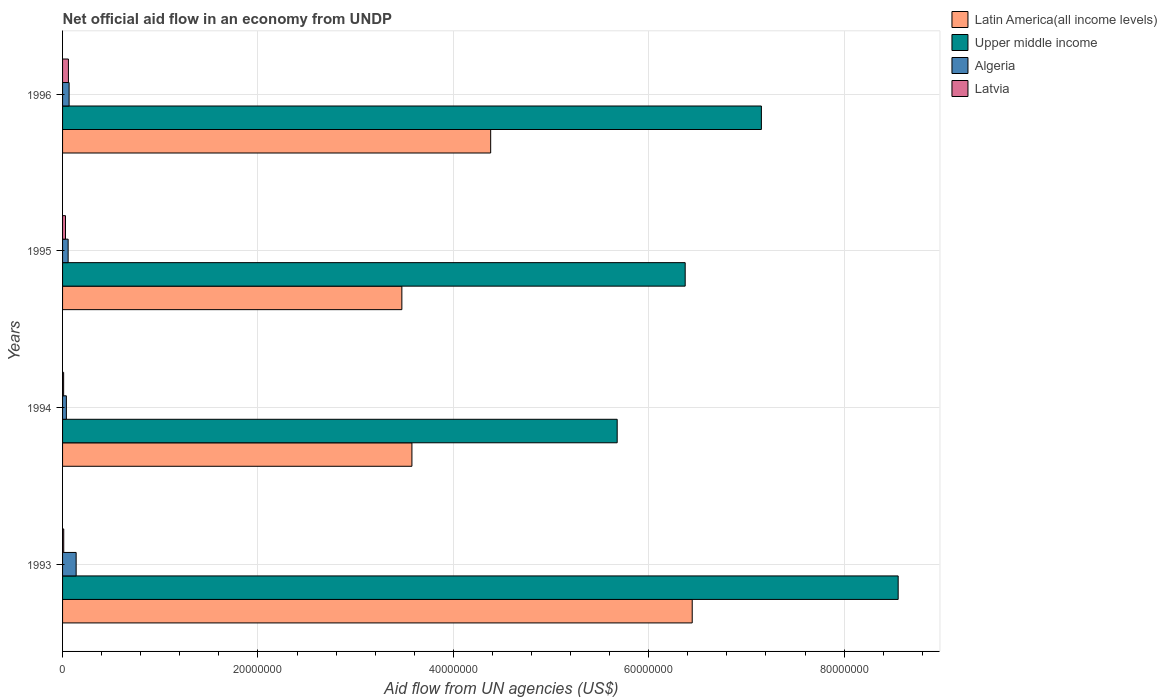Are the number of bars per tick equal to the number of legend labels?
Give a very brief answer. Yes. How many bars are there on the 2nd tick from the top?
Give a very brief answer. 4. In how many cases, is the number of bars for a given year not equal to the number of legend labels?
Make the answer very short. 0. What is the net official aid flow in Algeria in 1994?
Ensure brevity in your answer.  3.90e+05. Across all years, what is the maximum net official aid flow in Upper middle income?
Give a very brief answer. 8.55e+07. What is the total net official aid flow in Latvia in the graph?
Provide a succinct answer. 1.13e+06. What is the difference between the net official aid flow in Upper middle income in 1994 and that in 1996?
Give a very brief answer. -1.48e+07. What is the difference between the net official aid flow in Algeria in 1994 and the net official aid flow in Upper middle income in 1995?
Keep it short and to the point. -6.33e+07. What is the average net official aid flow in Latin America(all income levels) per year?
Give a very brief answer. 4.47e+07. In the year 1995, what is the difference between the net official aid flow in Algeria and net official aid flow in Latvia?
Ensure brevity in your answer.  2.70e+05. In how many years, is the net official aid flow in Algeria greater than 52000000 US$?
Provide a short and direct response. 0. What is the ratio of the net official aid flow in Upper middle income in 1993 to that in 1995?
Your answer should be very brief. 1.34. Is the net official aid flow in Latin America(all income levels) in 1993 less than that in 1996?
Your answer should be very brief. No. Is the difference between the net official aid flow in Algeria in 1993 and 1994 greater than the difference between the net official aid flow in Latvia in 1993 and 1994?
Ensure brevity in your answer.  Yes. What is the difference between the highest and the lowest net official aid flow in Latvia?
Keep it short and to the point. 4.90e+05. Is it the case that in every year, the sum of the net official aid flow in Algeria and net official aid flow in Upper middle income is greater than the sum of net official aid flow in Latin America(all income levels) and net official aid flow in Latvia?
Give a very brief answer. Yes. What does the 4th bar from the top in 1993 represents?
Offer a terse response. Latin America(all income levels). What does the 2nd bar from the bottom in 1996 represents?
Offer a terse response. Upper middle income. How many bars are there?
Ensure brevity in your answer.  16. How many years are there in the graph?
Your response must be concise. 4. What is the difference between two consecutive major ticks on the X-axis?
Keep it short and to the point. 2.00e+07. Are the values on the major ticks of X-axis written in scientific E-notation?
Offer a very short reply. No. Does the graph contain any zero values?
Offer a very short reply. No. Does the graph contain grids?
Offer a very short reply. Yes. What is the title of the graph?
Give a very brief answer. Net official aid flow in an economy from UNDP. What is the label or title of the X-axis?
Your answer should be very brief. Aid flow from UN agencies (US$). What is the Aid flow from UN agencies (US$) in Latin America(all income levels) in 1993?
Make the answer very short. 6.44e+07. What is the Aid flow from UN agencies (US$) of Upper middle income in 1993?
Give a very brief answer. 8.55e+07. What is the Aid flow from UN agencies (US$) in Algeria in 1993?
Provide a succinct answer. 1.39e+06. What is the Aid flow from UN agencies (US$) in Latvia in 1993?
Ensure brevity in your answer.  1.20e+05. What is the Aid flow from UN agencies (US$) in Latin America(all income levels) in 1994?
Your answer should be compact. 3.58e+07. What is the Aid flow from UN agencies (US$) in Upper middle income in 1994?
Offer a terse response. 5.68e+07. What is the Aid flow from UN agencies (US$) in Algeria in 1994?
Ensure brevity in your answer.  3.90e+05. What is the Aid flow from UN agencies (US$) in Latvia in 1994?
Provide a short and direct response. 1.10e+05. What is the Aid flow from UN agencies (US$) in Latin America(all income levels) in 1995?
Ensure brevity in your answer.  3.47e+07. What is the Aid flow from UN agencies (US$) of Upper middle income in 1995?
Your answer should be compact. 6.37e+07. What is the Aid flow from UN agencies (US$) in Algeria in 1995?
Provide a succinct answer. 5.70e+05. What is the Aid flow from UN agencies (US$) in Latin America(all income levels) in 1996?
Your answer should be very brief. 4.38e+07. What is the Aid flow from UN agencies (US$) in Upper middle income in 1996?
Make the answer very short. 7.15e+07. What is the Aid flow from UN agencies (US$) of Algeria in 1996?
Your answer should be compact. 6.70e+05. What is the Aid flow from UN agencies (US$) in Latvia in 1996?
Offer a very short reply. 6.00e+05. Across all years, what is the maximum Aid flow from UN agencies (US$) of Latin America(all income levels)?
Keep it short and to the point. 6.44e+07. Across all years, what is the maximum Aid flow from UN agencies (US$) in Upper middle income?
Provide a short and direct response. 8.55e+07. Across all years, what is the maximum Aid flow from UN agencies (US$) in Algeria?
Your answer should be compact. 1.39e+06. Across all years, what is the minimum Aid flow from UN agencies (US$) of Latin America(all income levels)?
Ensure brevity in your answer.  3.47e+07. Across all years, what is the minimum Aid flow from UN agencies (US$) in Upper middle income?
Your response must be concise. 5.68e+07. What is the total Aid flow from UN agencies (US$) of Latin America(all income levels) in the graph?
Offer a terse response. 1.79e+08. What is the total Aid flow from UN agencies (US$) in Upper middle income in the graph?
Offer a very short reply. 2.78e+08. What is the total Aid flow from UN agencies (US$) of Algeria in the graph?
Your answer should be compact. 3.02e+06. What is the total Aid flow from UN agencies (US$) of Latvia in the graph?
Provide a short and direct response. 1.13e+06. What is the difference between the Aid flow from UN agencies (US$) of Latin America(all income levels) in 1993 and that in 1994?
Give a very brief answer. 2.87e+07. What is the difference between the Aid flow from UN agencies (US$) of Upper middle income in 1993 and that in 1994?
Ensure brevity in your answer.  2.88e+07. What is the difference between the Aid flow from UN agencies (US$) in Algeria in 1993 and that in 1994?
Ensure brevity in your answer.  1.00e+06. What is the difference between the Aid flow from UN agencies (US$) of Latvia in 1993 and that in 1994?
Offer a very short reply. 10000. What is the difference between the Aid flow from UN agencies (US$) of Latin America(all income levels) in 1993 and that in 1995?
Your response must be concise. 2.97e+07. What is the difference between the Aid flow from UN agencies (US$) of Upper middle income in 1993 and that in 1995?
Your response must be concise. 2.18e+07. What is the difference between the Aid flow from UN agencies (US$) of Algeria in 1993 and that in 1995?
Keep it short and to the point. 8.20e+05. What is the difference between the Aid flow from UN agencies (US$) in Latin America(all income levels) in 1993 and that in 1996?
Your response must be concise. 2.06e+07. What is the difference between the Aid flow from UN agencies (US$) of Upper middle income in 1993 and that in 1996?
Make the answer very short. 1.40e+07. What is the difference between the Aid flow from UN agencies (US$) of Algeria in 1993 and that in 1996?
Provide a succinct answer. 7.20e+05. What is the difference between the Aid flow from UN agencies (US$) in Latvia in 1993 and that in 1996?
Your answer should be compact. -4.80e+05. What is the difference between the Aid flow from UN agencies (US$) in Latin America(all income levels) in 1994 and that in 1995?
Provide a succinct answer. 1.03e+06. What is the difference between the Aid flow from UN agencies (US$) of Upper middle income in 1994 and that in 1995?
Give a very brief answer. -6.96e+06. What is the difference between the Aid flow from UN agencies (US$) of Algeria in 1994 and that in 1995?
Make the answer very short. -1.80e+05. What is the difference between the Aid flow from UN agencies (US$) of Latin America(all income levels) in 1994 and that in 1996?
Your response must be concise. -8.06e+06. What is the difference between the Aid flow from UN agencies (US$) of Upper middle income in 1994 and that in 1996?
Make the answer very short. -1.48e+07. What is the difference between the Aid flow from UN agencies (US$) in Algeria in 1994 and that in 1996?
Provide a succinct answer. -2.80e+05. What is the difference between the Aid flow from UN agencies (US$) in Latvia in 1994 and that in 1996?
Offer a very short reply. -4.90e+05. What is the difference between the Aid flow from UN agencies (US$) in Latin America(all income levels) in 1995 and that in 1996?
Give a very brief answer. -9.09e+06. What is the difference between the Aid flow from UN agencies (US$) of Upper middle income in 1995 and that in 1996?
Provide a short and direct response. -7.80e+06. What is the difference between the Aid flow from UN agencies (US$) of Algeria in 1995 and that in 1996?
Your response must be concise. -1.00e+05. What is the difference between the Aid flow from UN agencies (US$) in Latin America(all income levels) in 1993 and the Aid flow from UN agencies (US$) in Upper middle income in 1994?
Your response must be concise. 7.68e+06. What is the difference between the Aid flow from UN agencies (US$) of Latin America(all income levels) in 1993 and the Aid flow from UN agencies (US$) of Algeria in 1994?
Provide a short and direct response. 6.41e+07. What is the difference between the Aid flow from UN agencies (US$) in Latin America(all income levels) in 1993 and the Aid flow from UN agencies (US$) in Latvia in 1994?
Ensure brevity in your answer.  6.43e+07. What is the difference between the Aid flow from UN agencies (US$) in Upper middle income in 1993 and the Aid flow from UN agencies (US$) in Algeria in 1994?
Your response must be concise. 8.51e+07. What is the difference between the Aid flow from UN agencies (US$) of Upper middle income in 1993 and the Aid flow from UN agencies (US$) of Latvia in 1994?
Ensure brevity in your answer.  8.54e+07. What is the difference between the Aid flow from UN agencies (US$) in Algeria in 1993 and the Aid flow from UN agencies (US$) in Latvia in 1994?
Your response must be concise. 1.28e+06. What is the difference between the Aid flow from UN agencies (US$) of Latin America(all income levels) in 1993 and the Aid flow from UN agencies (US$) of Upper middle income in 1995?
Provide a succinct answer. 7.20e+05. What is the difference between the Aid flow from UN agencies (US$) in Latin America(all income levels) in 1993 and the Aid flow from UN agencies (US$) in Algeria in 1995?
Keep it short and to the point. 6.39e+07. What is the difference between the Aid flow from UN agencies (US$) in Latin America(all income levels) in 1993 and the Aid flow from UN agencies (US$) in Latvia in 1995?
Your response must be concise. 6.42e+07. What is the difference between the Aid flow from UN agencies (US$) of Upper middle income in 1993 and the Aid flow from UN agencies (US$) of Algeria in 1995?
Make the answer very short. 8.50e+07. What is the difference between the Aid flow from UN agencies (US$) in Upper middle income in 1993 and the Aid flow from UN agencies (US$) in Latvia in 1995?
Offer a very short reply. 8.52e+07. What is the difference between the Aid flow from UN agencies (US$) in Algeria in 1993 and the Aid flow from UN agencies (US$) in Latvia in 1995?
Give a very brief answer. 1.09e+06. What is the difference between the Aid flow from UN agencies (US$) in Latin America(all income levels) in 1993 and the Aid flow from UN agencies (US$) in Upper middle income in 1996?
Provide a short and direct response. -7.08e+06. What is the difference between the Aid flow from UN agencies (US$) of Latin America(all income levels) in 1993 and the Aid flow from UN agencies (US$) of Algeria in 1996?
Keep it short and to the point. 6.38e+07. What is the difference between the Aid flow from UN agencies (US$) of Latin America(all income levels) in 1993 and the Aid flow from UN agencies (US$) of Latvia in 1996?
Provide a succinct answer. 6.38e+07. What is the difference between the Aid flow from UN agencies (US$) of Upper middle income in 1993 and the Aid flow from UN agencies (US$) of Algeria in 1996?
Offer a terse response. 8.49e+07. What is the difference between the Aid flow from UN agencies (US$) in Upper middle income in 1993 and the Aid flow from UN agencies (US$) in Latvia in 1996?
Make the answer very short. 8.49e+07. What is the difference between the Aid flow from UN agencies (US$) in Algeria in 1993 and the Aid flow from UN agencies (US$) in Latvia in 1996?
Your answer should be compact. 7.90e+05. What is the difference between the Aid flow from UN agencies (US$) in Latin America(all income levels) in 1994 and the Aid flow from UN agencies (US$) in Upper middle income in 1995?
Keep it short and to the point. -2.80e+07. What is the difference between the Aid flow from UN agencies (US$) of Latin America(all income levels) in 1994 and the Aid flow from UN agencies (US$) of Algeria in 1995?
Offer a terse response. 3.52e+07. What is the difference between the Aid flow from UN agencies (US$) of Latin America(all income levels) in 1994 and the Aid flow from UN agencies (US$) of Latvia in 1995?
Your response must be concise. 3.55e+07. What is the difference between the Aid flow from UN agencies (US$) of Upper middle income in 1994 and the Aid flow from UN agencies (US$) of Algeria in 1995?
Make the answer very short. 5.62e+07. What is the difference between the Aid flow from UN agencies (US$) in Upper middle income in 1994 and the Aid flow from UN agencies (US$) in Latvia in 1995?
Give a very brief answer. 5.65e+07. What is the difference between the Aid flow from UN agencies (US$) of Latin America(all income levels) in 1994 and the Aid flow from UN agencies (US$) of Upper middle income in 1996?
Provide a short and direct response. -3.58e+07. What is the difference between the Aid flow from UN agencies (US$) in Latin America(all income levels) in 1994 and the Aid flow from UN agencies (US$) in Algeria in 1996?
Your answer should be compact. 3.51e+07. What is the difference between the Aid flow from UN agencies (US$) in Latin America(all income levels) in 1994 and the Aid flow from UN agencies (US$) in Latvia in 1996?
Your answer should be very brief. 3.52e+07. What is the difference between the Aid flow from UN agencies (US$) in Upper middle income in 1994 and the Aid flow from UN agencies (US$) in Algeria in 1996?
Offer a very short reply. 5.61e+07. What is the difference between the Aid flow from UN agencies (US$) of Upper middle income in 1994 and the Aid flow from UN agencies (US$) of Latvia in 1996?
Offer a very short reply. 5.62e+07. What is the difference between the Aid flow from UN agencies (US$) in Algeria in 1994 and the Aid flow from UN agencies (US$) in Latvia in 1996?
Ensure brevity in your answer.  -2.10e+05. What is the difference between the Aid flow from UN agencies (US$) of Latin America(all income levels) in 1995 and the Aid flow from UN agencies (US$) of Upper middle income in 1996?
Keep it short and to the point. -3.68e+07. What is the difference between the Aid flow from UN agencies (US$) of Latin America(all income levels) in 1995 and the Aid flow from UN agencies (US$) of Algeria in 1996?
Keep it short and to the point. 3.41e+07. What is the difference between the Aid flow from UN agencies (US$) in Latin America(all income levels) in 1995 and the Aid flow from UN agencies (US$) in Latvia in 1996?
Provide a short and direct response. 3.41e+07. What is the difference between the Aid flow from UN agencies (US$) of Upper middle income in 1995 and the Aid flow from UN agencies (US$) of Algeria in 1996?
Provide a short and direct response. 6.31e+07. What is the difference between the Aid flow from UN agencies (US$) in Upper middle income in 1995 and the Aid flow from UN agencies (US$) in Latvia in 1996?
Ensure brevity in your answer.  6.31e+07. What is the average Aid flow from UN agencies (US$) in Latin America(all income levels) per year?
Offer a terse response. 4.47e+07. What is the average Aid flow from UN agencies (US$) of Upper middle income per year?
Keep it short and to the point. 6.94e+07. What is the average Aid flow from UN agencies (US$) in Algeria per year?
Your answer should be compact. 7.55e+05. What is the average Aid flow from UN agencies (US$) in Latvia per year?
Your answer should be compact. 2.82e+05. In the year 1993, what is the difference between the Aid flow from UN agencies (US$) in Latin America(all income levels) and Aid flow from UN agencies (US$) in Upper middle income?
Provide a succinct answer. -2.11e+07. In the year 1993, what is the difference between the Aid flow from UN agencies (US$) of Latin America(all income levels) and Aid flow from UN agencies (US$) of Algeria?
Your answer should be very brief. 6.31e+07. In the year 1993, what is the difference between the Aid flow from UN agencies (US$) in Latin America(all income levels) and Aid flow from UN agencies (US$) in Latvia?
Provide a short and direct response. 6.43e+07. In the year 1993, what is the difference between the Aid flow from UN agencies (US$) of Upper middle income and Aid flow from UN agencies (US$) of Algeria?
Your answer should be very brief. 8.41e+07. In the year 1993, what is the difference between the Aid flow from UN agencies (US$) in Upper middle income and Aid flow from UN agencies (US$) in Latvia?
Give a very brief answer. 8.54e+07. In the year 1993, what is the difference between the Aid flow from UN agencies (US$) of Algeria and Aid flow from UN agencies (US$) of Latvia?
Your answer should be very brief. 1.27e+06. In the year 1994, what is the difference between the Aid flow from UN agencies (US$) in Latin America(all income levels) and Aid flow from UN agencies (US$) in Upper middle income?
Your response must be concise. -2.10e+07. In the year 1994, what is the difference between the Aid flow from UN agencies (US$) of Latin America(all income levels) and Aid flow from UN agencies (US$) of Algeria?
Keep it short and to the point. 3.54e+07. In the year 1994, what is the difference between the Aid flow from UN agencies (US$) in Latin America(all income levels) and Aid flow from UN agencies (US$) in Latvia?
Your answer should be compact. 3.56e+07. In the year 1994, what is the difference between the Aid flow from UN agencies (US$) in Upper middle income and Aid flow from UN agencies (US$) in Algeria?
Offer a very short reply. 5.64e+07. In the year 1994, what is the difference between the Aid flow from UN agencies (US$) in Upper middle income and Aid flow from UN agencies (US$) in Latvia?
Provide a short and direct response. 5.67e+07. In the year 1994, what is the difference between the Aid flow from UN agencies (US$) of Algeria and Aid flow from UN agencies (US$) of Latvia?
Make the answer very short. 2.80e+05. In the year 1995, what is the difference between the Aid flow from UN agencies (US$) in Latin America(all income levels) and Aid flow from UN agencies (US$) in Upper middle income?
Provide a succinct answer. -2.90e+07. In the year 1995, what is the difference between the Aid flow from UN agencies (US$) of Latin America(all income levels) and Aid flow from UN agencies (US$) of Algeria?
Offer a very short reply. 3.42e+07. In the year 1995, what is the difference between the Aid flow from UN agencies (US$) in Latin America(all income levels) and Aid flow from UN agencies (US$) in Latvia?
Your answer should be very brief. 3.44e+07. In the year 1995, what is the difference between the Aid flow from UN agencies (US$) of Upper middle income and Aid flow from UN agencies (US$) of Algeria?
Make the answer very short. 6.32e+07. In the year 1995, what is the difference between the Aid flow from UN agencies (US$) in Upper middle income and Aid flow from UN agencies (US$) in Latvia?
Keep it short and to the point. 6.34e+07. In the year 1996, what is the difference between the Aid flow from UN agencies (US$) in Latin America(all income levels) and Aid flow from UN agencies (US$) in Upper middle income?
Your answer should be very brief. -2.77e+07. In the year 1996, what is the difference between the Aid flow from UN agencies (US$) of Latin America(all income levels) and Aid flow from UN agencies (US$) of Algeria?
Ensure brevity in your answer.  4.32e+07. In the year 1996, what is the difference between the Aid flow from UN agencies (US$) of Latin America(all income levels) and Aid flow from UN agencies (US$) of Latvia?
Provide a short and direct response. 4.32e+07. In the year 1996, what is the difference between the Aid flow from UN agencies (US$) of Upper middle income and Aid flow from UN agencies (US$) of Algeria?
Make the answer very short. 7.09e+07. In the year 1996, what is the difference between the Aid flow from UN agencies (US$) in Upper middle income and Aid flow from UN agencies (US$) in Latvia?
Offer a terse response. 7.09e+07. What is the ratio of the Aid flow from UN agencies (US$) in Latin America(all income levels) in 1993 to that in 1994?
Keep it short and to the point. 1.8. What is the ratio of the Aid flow from UN agencies (US$) in Upper middle income in 1993 to that in 1994?
Provide a short and direct response. 1.51. What is the ratio of the Aid flow from UN agencies (US$) in Algeria in 1993 to that in 1994?
Give a very brief answer. 3.56. What is the ratio of the Aid flow from UN agencies (US$) of Latvia in 1993 to that in 1994?
Your response must be concise. 1.09. What is the ratio of the Aid flow from UN agencies (US$) of Latin America(all income levels) in 1993 to that in 1995?
Ensure brevity in your answer.  1.86. What is the ratio of the Aid flow from UN agencies (US$) of Upper middle income in 1993 to that in 1995?
Ensure brevity in your answer.  1.34. What is the ratio of the Aid flow from UN agencies (US$) of Algeria in 1993 to that in 1995?
Give a very brief answer. 2.44. What is the ratio of the Aid flow from UN agencies (US$) of Latin America(all income levels) in 1993 to that in 1996?
Offer a terse response. 1.47. What is the ratio of the Aid flow from UN agencies (US$) in Upper middle income in 1993 to that in 1996?
Your response must be concise. 1.2. What is the ratio of the Aid flow from UN agencies (US$) in Algeria in 1993 to that in 1996?
Your response must be concise. 2.07. What is the ratio of the Aid flow from UN agencies (US$) of Latin America(all income levels) in 1994 to that in 1995?
Your response must be concise. 1.03. What is the ratio of the Aid flow from UN agencies (US$) of Upper middle income in 1994 to that in 1995?
Offer a terse response. 0.89. What is the ratio of the Aid flow from UN agencies (US$) of Algeria in 1994 to that in 1995?
Your response must be concise. 0.68. What is the ratio of the Aid flow from UN agencies (US$) of Latvia in 1994 to that in 1995?
Give a very brief answer. 0.37. What is the ratio of the Aid flow from UN agencies (US$) of Latin America(all income levels) in 1994 to that in 1996?
Offer a terse response. 0.82. What is the ratio of the Aid flow from UN agencies (US$) of Upper middle income in 1994 to that in 1996?
Your response must be concise. 0.79. What is the ratio of the Aid flow from UN agencies (US$) of Algeria in 1994 to that in 1996?
Keep it short and to the point. 0.58. What is the ratio of the Aid flow from UN agencies (US$) of Latvia in 1994 to that in 1996?
Give a very brief answer. 0.18. What is the ratio of the Aid flow from UN agencies (US$) of Latin America(all income levels) in 1995 to that in 1996?
Give a very brief answer. 0.79. What is the ratio of the Aid flow from UN agencies (US$) in Upper middle income in 1995 to that in 1996?
Make the answer very short. 0.89. What is the ratio of the Aid flow from UN agencies (US$) in Algeria in 1995 to that in 1996?
Ensure brevity in your answer.  0.85. What is the ratio of the Aid flow from UN agencies (US$) of Latvia in 1995 to that in 1996?
Provide a succinct answer. 0.5. What is the difference between the highest and the second highest Aid flow from UN agencies (US$) of Latin America(all income levels)?
Your answer should be compact. 2.06e+07. What is the difference between the highest and the second highest Aid flow from UN agencies (US$) of Upper middle income?
Give a very brief answer. 1.40e+07. What is the difference between the highest and the second highest Aid flow from UN agencies (US$) in Algeria?
Your answer should be compact. 7.20e+05. What is the difference between the highest and the lowest Aid flow from UN agencies (US$) in Latin America(all income levels)?
Your response must be concise. 2.97e+07. What is the difference between the highest and the lowest Aid flow from UN agencies (US$) of Upper middle income?
Your answer should be very brief. 2.88e+07. What is the difference between the highest and the lowest Aid flow from UN agencies (US$) of Latvia?
Give a very brief answer. 4.90e+05. 